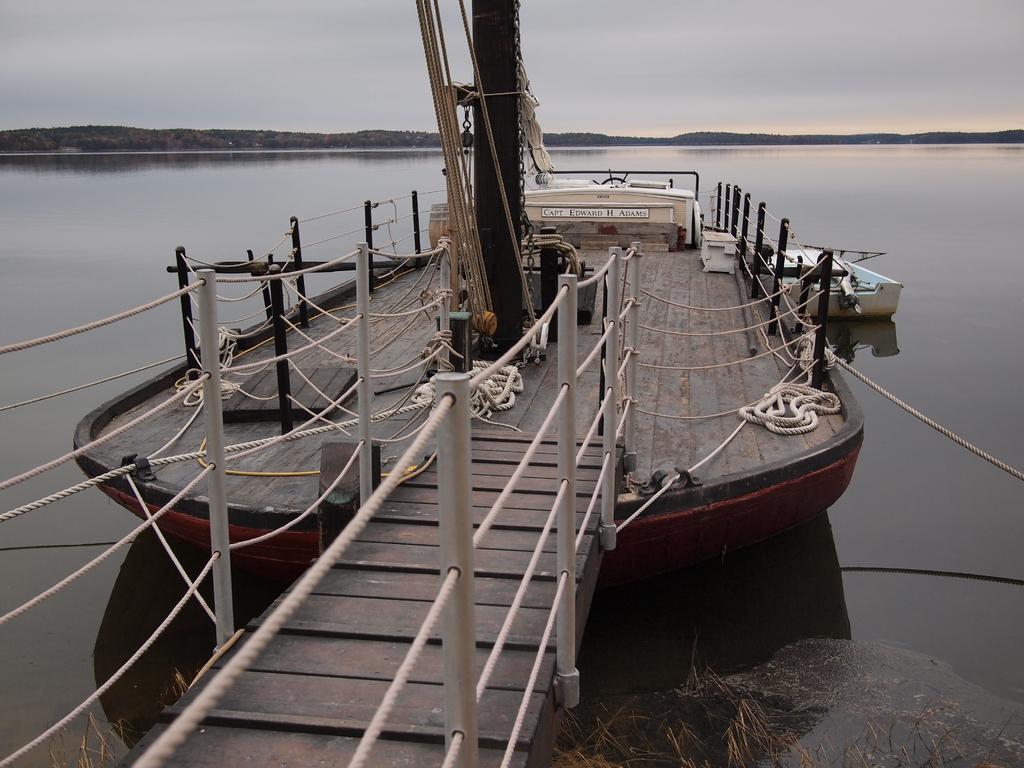Could you give a brief overview of what you see in this image? In the center of the image we can see a boat with some ropes and poles. We can also see a boat in a water body and a wooden pathway tied with the ropes. On the backside we can see the hills and the sky which looks cloudy. 